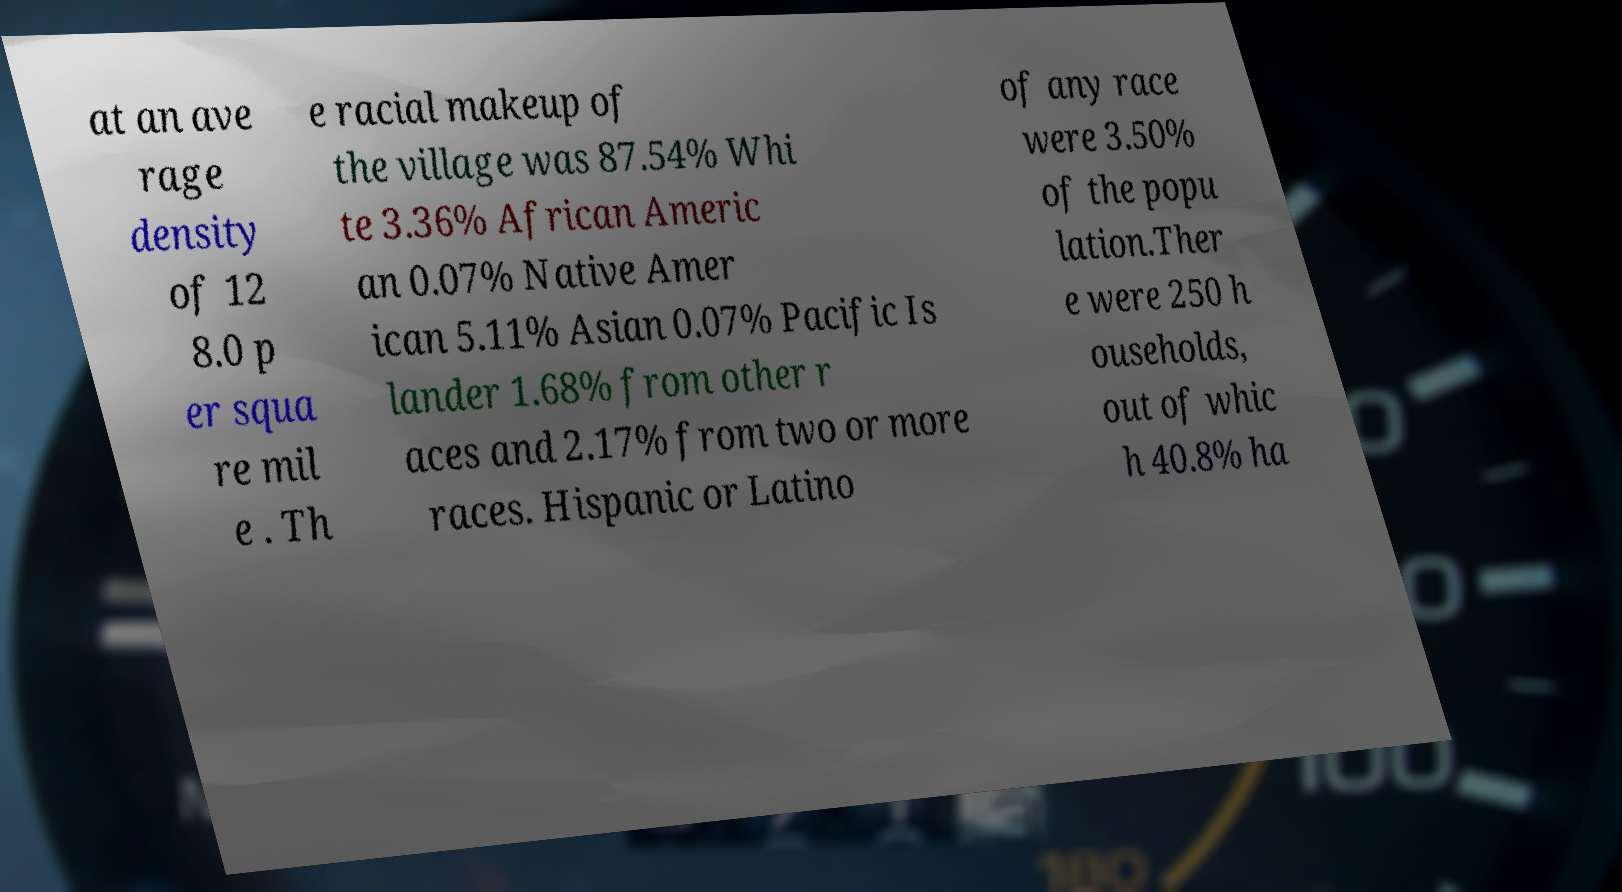What messages or text are displayed in this image? I need them in a readable, typed format. at an ave rage density of 12 8.0 p er squa re mil e . Th e racial makeup of the village was 87.54% Whi te 3.36% African Americ an 0.07% Native Amer ican 5.11% Asian 0.07% Pacific Is lander 1.68% from other r aces and 2.17% from two or more races. Hispanic or Latino of any race were 3.50% of the popu lation.Ther e were 250 h ouseholds, out of whic h 40.8% ha 